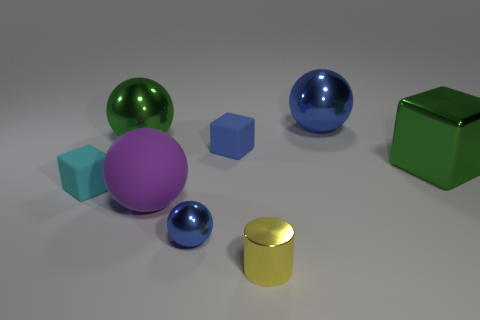How many small objects are the same color as the small ball?
Provide a succinct answer. 1. There is a blue ball that is on the right side of the blue cube; are there any big green metallic balls that are left of it?
Keep it short and to the point. Yes. What number of shiny things are in front of the large green block and behind the small yellow thing?
Offer a terse response. 1. What number of spheres are made of the same material as the big blue object?
Ensure brevity in your answer.  2. What is the size of the green metallic thing to the left of the big blue shiny ball that is right of the blue block?
Provide a short and direct response. Large. Is there a yellow metal object that has the same shape as the big matte object?
Your answer should be compact. No. There is a ball in front of the matte sphere; does it have the same size as the blue sphere right of the small shiny cylinder?
Make the answer very short. No. Is the number of cyan rubber blocks on the right side of the big purple matte thing less than the number of big blue shiny things that are to the right of the green cube?
Give a very brief answer. No. What is the material of the other ball that is the same color as the tiny metallic sphere?
Offer a very short reply. Metal. What color is the tiny matte object that is to the left of the tiny blue ball?
Give a very brief answer. Cyan. 